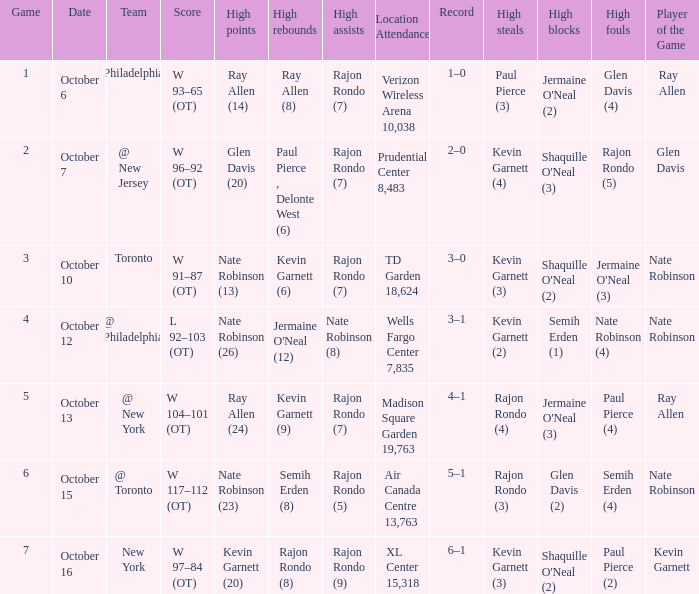Who obtained the most rebounds and what quantity did they achieve on october 16? Rajon Rondo (8). 